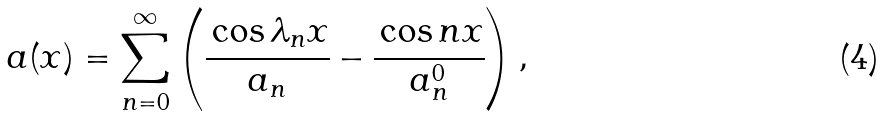Convert formula to latex. <formula><loc_0><loc_0><loc_500><loc_500>a ( x ) = \sum _ { n = 0 } ^ { \infty } \left ( \cfrac { \cos \lambda _ { n } x } { a _ { n } } - \cfrac { \cos n x } { a _ { n } ^ { 0 } } \right ) ,</formula> 